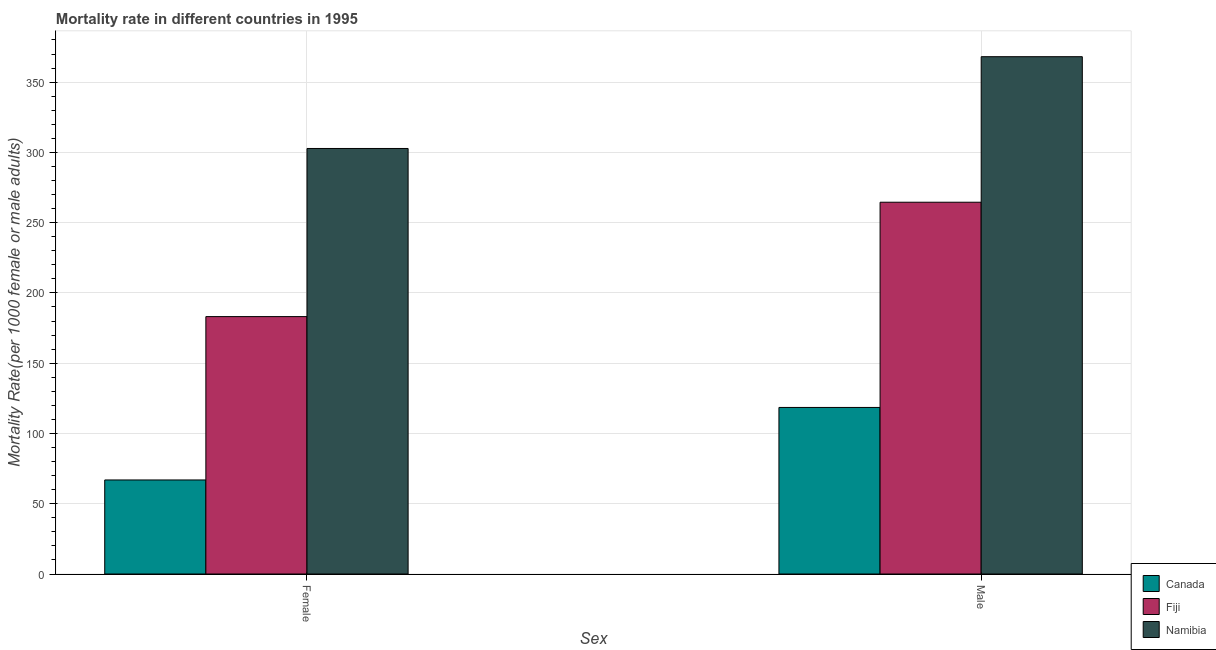Are the number of bars per tick equal to the number of legend labels?
Your answer should be very brief. Yes. What is the label of the 2nd group of bars from the left?
Ensure brevity in your answer.  Male. What is the male mortality rate in Namibia?
Offer a terse response. 368.09. Across all countries, what is the maximum female mortality rate?
Provide a short and direct response. 302.77. Across all countries, what is the minimum male mortality rate?
Offer a terse response. 118.51. In which country was the male mortality rate maximum?
Ensure brevity in your answer.  Namibia. In which country was the female mortality rate minimum?
Give a very brief answer. Canada. What is the total female mortality rate in the graph?
Make the answer very short. 552.84. What is the difference between the female mortality rate in Fiji and that in Namibia?
Your response must be concise. -119.62. What is the difference between the female mortality rate in Namibia and the male mortality rate in Fiji?
Keep it short and to the point. 38.25. What is the average male mortality rate per country?
Your answer should be very brief. 250.38. What is the difference between the male mortality rate and female mortality rate in Namibia?
Give a very brief answer. 65.31. In how many countries, is the male mortality rate greater than 40 ?
Provide a short and direct response. 3. What is the ratio of the female mortality rate in Fiji to that in Namibia?
Offer a terse response. 0.6. What does the 3rd bar from the left in Female represents?
Keep it short and to the point. Namibia. What does the 1st bar from the right in Male represents?
Your answer should be very brief. Namibia. How many countries are there in the graph?
Offer a very short reply. 3. What is the difference between two consecutive major ticks on the Y-axis?
Ensure brevity in your answer.  50. Does the graph contain grids?
Offer a very short reply. Yes. How many legend labels are there?
Offer a terse response. 3. How are the legend labels stacked?
Keep it short and to the point. Vertical. What is the title of the graph?
Provide a succinct answer. Mortality rate in different countries in 1995. Does "Qatar" appear as one of the legend labels in the graph?
Offer a very short reply. No. What is the label or title of the X-axis?
Offer a terse response. Sex. What is the label or title of the Y-axis?
Ensure brevity in your answer.  Mortality Rate(per 1000 female or male adults). What is the Mortality Rate(per 1000 female or male adults) of Canada in Female?
Offer a terse response. 66.91. What is the Mortality Rate(per 1000 female or male adults) of Fiji in Female?
Your response must be concise. 183.15. What is the Mortality Rate(per 1000 female or male adults) in Namibia in Female?
Provide a short and direct response. 302.77. What is the Mortality Rate(per 1000 female or male adults) in Canada in Male?
Ensure brevity in your answer.  118.51. What is the Mortality Rate(per 1000 female or male adults) in Fiji in Male?
Keep it short and to the point. 264.53. What is the Mortality Rate(per 1000 female or male adults) in Namibia in Male?
Your answer should be compact. 368.09. Across all Sex, what is the maximum Mortality Rate(per 1000 female or male adults) in Canada?
Your answer should be compact. 118.51. Across all Sex, what is the maximum Mortality Rate(per 1000 female or male adults) of Fiji?
Provide a short and direct response. 264.53. Across all Sex, what is the maximum Mortality Rate(per 1000 female or male adults) of Namibia?
Provide a short and direct response. 368.09. Across all Sex, what is the minimum Mortality Rate(per 1000 female or male adults) in Canada?
Make the answer very short. 66.91. Across all Sex, what is the minimum Mortality Rate(per 1000 female or male adults) in Fiji?
Offer a terse response. 183.15. Across all Sex, what is the minimum Mortality Rate(per 1000 female or male adults) of Namibia?
Your answer should be very brief. 302.77. What is the total Mortality Rate(per 1000 female or male adults) of Canada in the graph?
Provide a short and direct response. 185.42. What is the total Mortality Rate(per 1000 female or male adults) in Fiji in the graph?
Ensure brevity in your answer.  447.68. What is the total Mortality Rate(per 1000 female or male adults) of Namibia in the graph?
Your answer should be compact. 670.86. What is the difference between the Mortality Rate(per 1000 female or male adults) in Canada in Female and that in Male?
Your answer should be compact. -51.6. What is the difference between the Mortality Rate(per 1000 female or male adults) of Fiji in Female and that in Male?
Offer a very short reply. -81.38. What is the difference between the Mortality Rate(per 1000 female or male adults) in Namibia in Female and that in Male?
Offer a terse response. -65.31. What is the difference between the Mortality Rate(per 1000 female or male adults) of Canada in Female and the Mortality Rate(per 1000 female or male adults) of Fiji in Male?
Provide a short and direct response. -197.62. What is the difference between the Mortality Rate(per 1000 female or male adults) in Canada in Female and the Mortality Rate(per 1000 female or male adults) in Namibia in Male?
Your answer should be compact. -301.18. What is the difference between the Mortality Rate(per 1000 female or male adults) of Fiji in Female and the Mortality Rate(per 1000 female or male adults) of Namibia in Male?
Provide a short and direct response. -184.94. What is the average Mortality Rate(per 1000 female or male adults) of Canada per Sex?
Offer a very short reply. 92.71. What is the average Mortality Rate(per 1000 female or male adults) in Fiji per Sex?
Provide a short and direct response. 223.84. What is the average Mortality Rate(per 1000 female or male adults) in Namibia per Sex?
Keep it short and to the point. 335.43. What is the difference between the Mortality Rate(per 1000 female or male adults) in Canada and Mortality Rate(per 1000 female or male adults) in Fiji in Female?
Ensure brevity in your answer.  -116.24. What is the difference between the Mortality Rate(per 1000 female or male adults) of Canada and Mortality Rate(per 1000 female or male adults) of Namibia in Female?
Keep it short and to the point. -235.86. What is the difference between the Mortality Rate(per 1000 female or male adults) of Fiji and Mortality Rate(per 1000 female or male adults) of Namibia in Female?
Make the answer very short. -119.62. What is the difference between the Mortality Rate(per 1000 female or male adults) in Canada and Mortality Rate(per 1000 female or male adults) in Fiji in Male?
Keep it short and to the point. -146.01. What is the difference between the Mortality Rate(per 1000 female or male adults) of Canada and Mortality Rate(per 1000 female or male adults) of Namibia in Male?
Ensure brevity in your answer.  -249.57. What is the difference between the Mortality Rate(per 1000 female or male adults) of Fiji and Mortality Rate(per 1000 female or male adults) of Namibia in Male?
Your answer should be very brief. -103.56. What is the ratio of the Mortality Rate(per 1000 female or male adults) of Canada in Female to that in Male?
Provide a short and direct response. 0.56. What is the ratio of the Mortality Rate(per 1000 female or male adults) in Fiji in Female to that in Male?
Keep it short and to the point. 0.69. What is the ratio of the Mortality Rate(per 1000 female or male adults) of Namibia in Female to that in Male?
Your answer should be very brief. 0.82. What is the difference between the highest and the second highest Mortality Rate(per 1000 female or male adults) in Canada?
Keep it short and to the point. 51.6. What is the difference between the highest and the second highest Mortality Rate(per 1000 female or male adults) in Fiji?
Provide a short and direct response. 81.38. What is the difference between the highest and the second highest Mortality Rate(per 1000 female or male adults) of Namibia?
Offer a very short reply. 65.31. What is the difference between the highest and the lowest Mortality Rate(per 1000 female or male adults) in Canada?
Make the answer very short. 51.6. What is the difference between the highest and the lowest Mortality Rate(per 1000 female or male adults) of Fiji?
Make the answer very short. 81.38. What is the difference between the highest and the lowest Mortality Rate(per 1000 female or male adults) of Namibia?
Your answer should be compact. 65.31. 